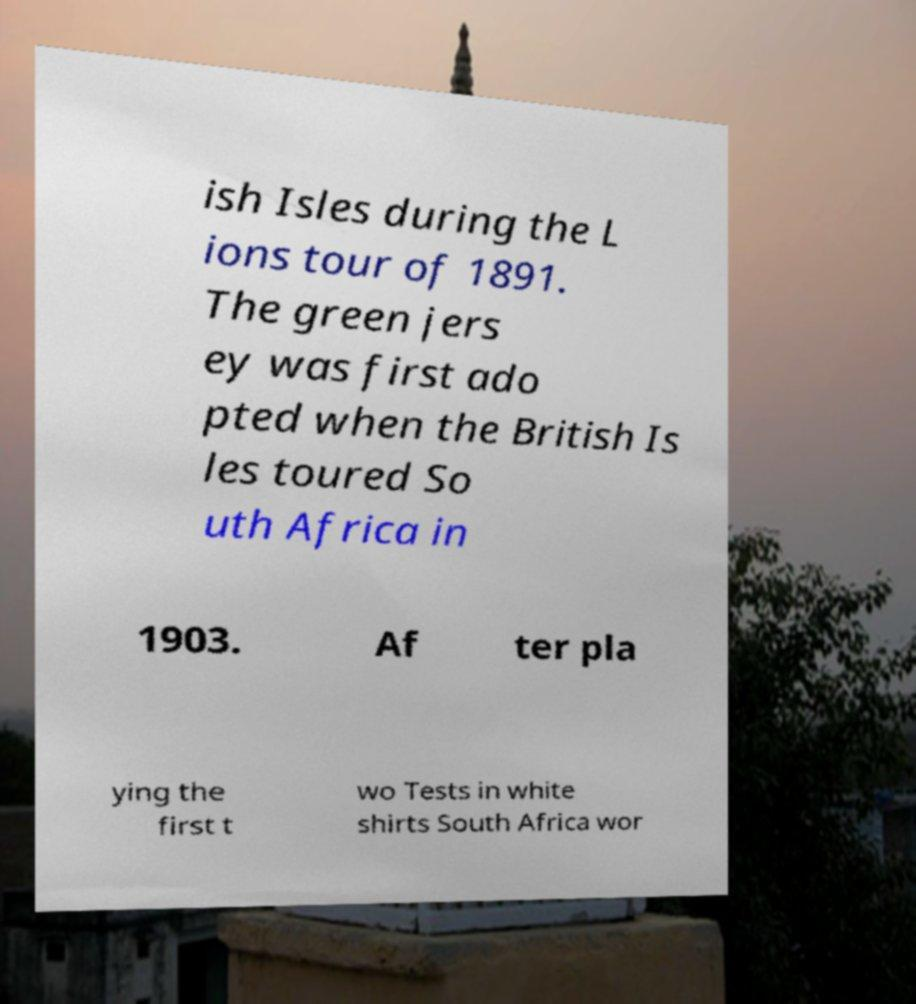I need the written content from this picture converted into text. Can you do that? ish Isles during the L ions tour of 1891. The green jers ey was first ado pted when the British Is les toured So uth Africa in 1903. Af ter pla ying the first t wo Tests in white shirts South Africa wor 